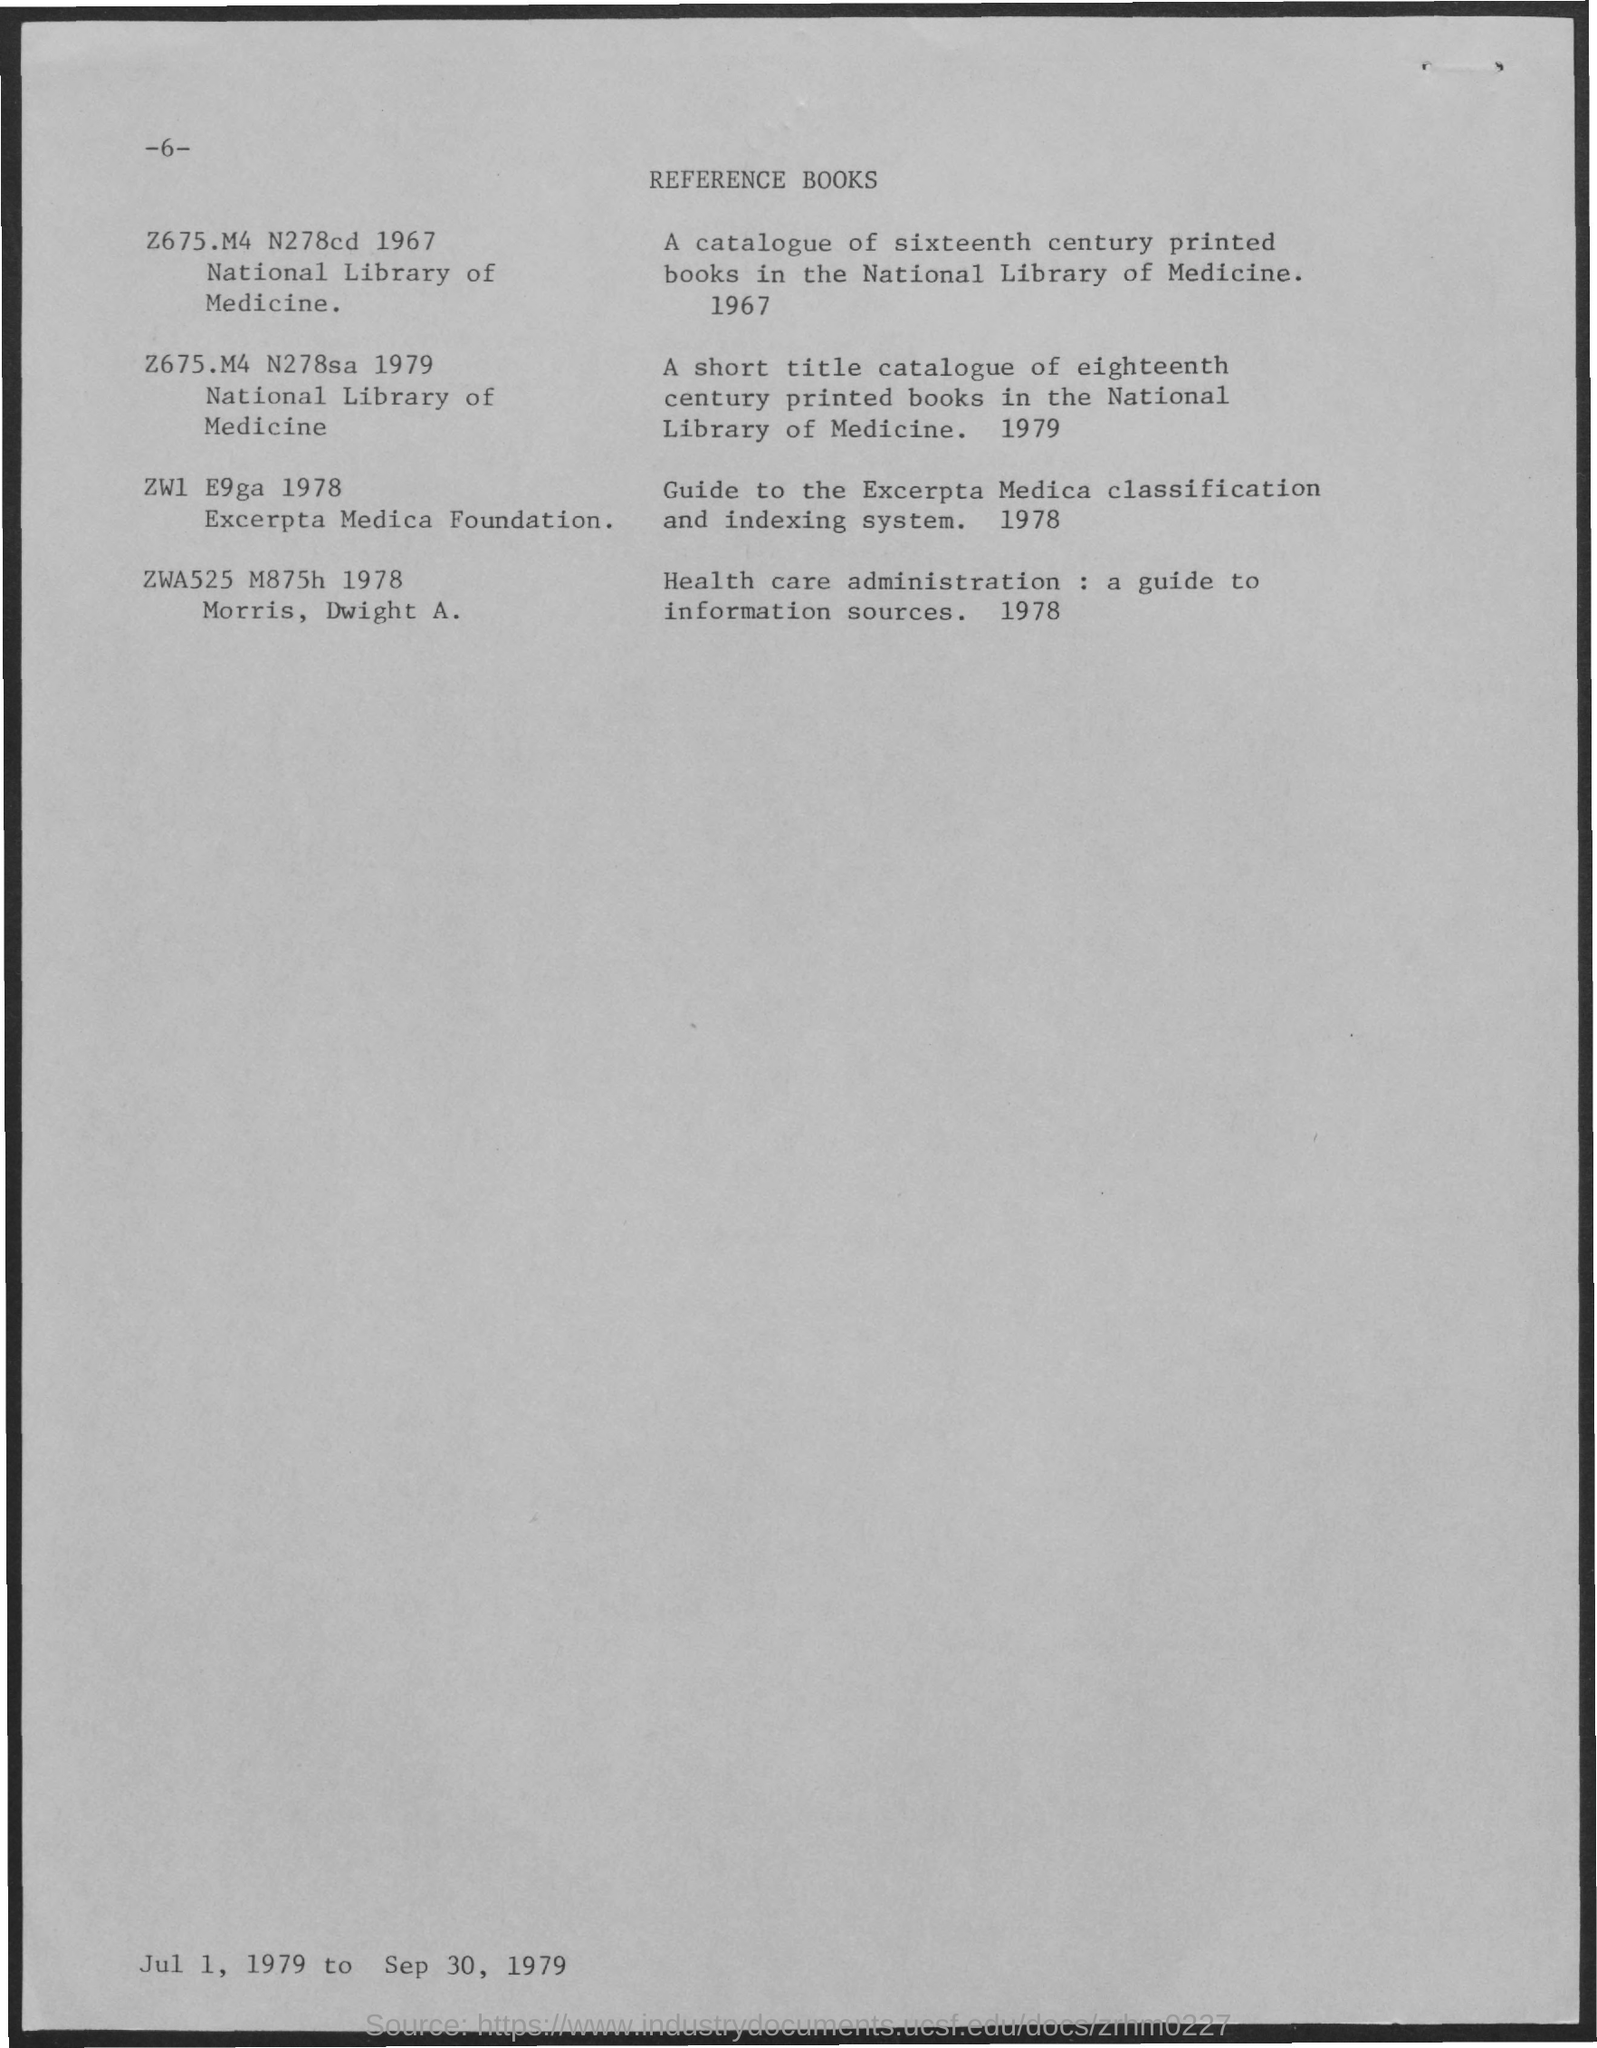Indicate a few pertinent items in this graphic. The page number is -6-. The Guide to the Excerpta Media Classification and Indexing System was published in 1978. The publication titled "Health care administration: a guide to information sources" was released in 1978. The title of the document is "The Importance of Math in Everyday Life" and it is referenced in several reference books. 